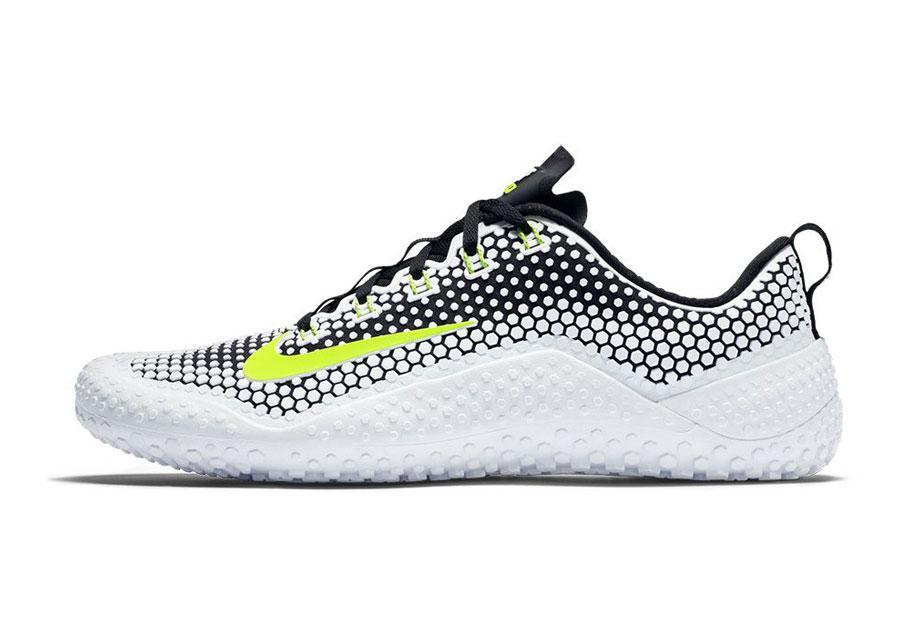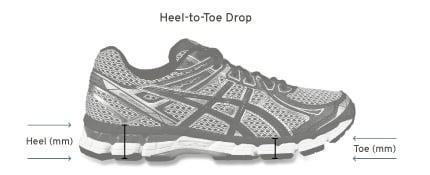The first image is the image on the left, the second image is the image on the right. Examine the images to the left and right. Is the description "There are more than two shoes pictured." accurate? Answer yes or no. No. The first image is the image on the left, the second image is the image on the right. Evaluate the accuracy of this statement regarding the images: "The left image contains a matched pair of unworn sneakers, and the right image features a sneaker that shares some of the color of the lefthand sneaker.". Is it true? Answer yes or no. No. 